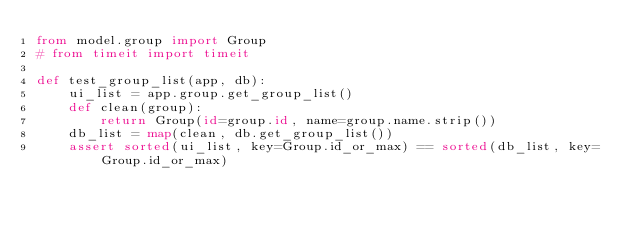Convert code to text. <code><loc_0><loc_0><loc_500><loc_500><_Python_>from model.group import Group
# from timeit import timeit

def test_group_list(app, db):
    ui_list = app.group.get_group_list()
    def clean(group):
        return Group(id=group.id, name=group.name.strip())
    db_list = map(clean, db.get_group_list())
    assert sorted(ui_list, key=Group.id_or_max) == sorted(db_list, key=Group.id_or_max)

</code> 